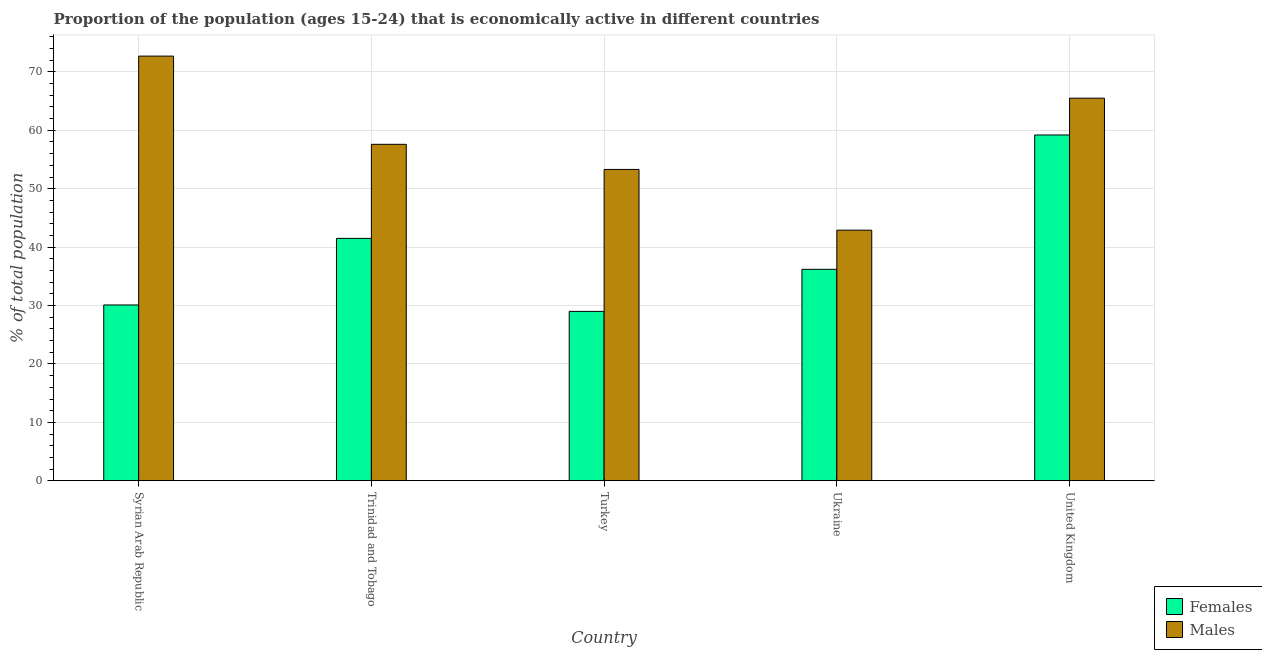How many different coloured bars are there?
Provide a succinct answer. 2. Are the number of bars per tick equal to the number of legend labels?
Ensure brevity in your answer.  Yes. Are the number of bars on each tick of the X-axis equal?
Ensure brevity in your answer.  Yes. How many bars are there on the 5th tick from the left?
Provide a succinct answer. 2. How many bars are there on the 1st tick from the right?
Your answer should be compact. 2. What is the label of the 4th group of bars from the left?
Keep it short and to the point. Ukraine. What is the percentage of economically active female population in Trinidad and Tobago?
Provide a short and direct response. 41.5. Across all countries, what is the maximum percentage of economically active male population?
Give a very brief answer. 72.7. Across all countries, what is the minimum percentage of economically active male population?
Give a very brief answer. 42.9. In which country was the percentage of economically active male population minimum?
Make the answer very short. Ukraine. What is the total percentage of economically active female population in the graph?
Your answer should be compact. 196. What is the difference between the percentage of economically active female population in Syrian Arab Republic and that in Trinidad and Tobago?
Make the answer very short. -11.4. What is the difference between the percentage of economically active male population in Syrian Arab Republic and the percentage of economically active female population in Trinidad and Tobago?
Offer a very short reply. 31.2. What is the average percentage of economically active male population per country?
Provide a succinct answer. 58.4. What is the difference between the percentage of economically active male population and percentage of economically active female population in Turkey?
Your answer should be very brief. 24.3. What is the ratio of the percentage of economically active female population in Turkey to that in Ukraine?
Your response must be concise. 0.8. What is the difference between the highest and the second highest percentage of economically active female population?
Your answer should be compact. 17.7. What is the difference between the highest and the lowest percentage of economically active male population?
Keep it short and to the point. 29.8. What does the 1st bar from the left in Syrian Arab Republic represents?
Ensure brevity in your answer.  Females. What does the 2nd bar from the right in United Kingdom represents?
Provide a succinct answer. Females. How many bars are there?
Offer a terse response. 10. Are all the bars in the graph horizontal?
Keep it short and to the point. No. How many countries are there in the graph?
Make the answer very short. 5. Are the values on the major ticks of Y-axis written in scientific E-notation?
Offer a very short reply. No. Does the graph contain any zero values?
Your answer should be very brief. No. Does the graph contain grids?
Give a very brief answer. Yes. How many legend labels are there?
Give a very brief answer. 2. What is the title of the graph?
Make the answer very short. Proportion of the population (ages 15-24) that is economically active in different countries. What is the label or title of the Y-axis?
Provide a short and direct response. % of total population. What is the % of total population in Females in Syrian Arab Republic?
Offer a terse response. 30.1. What is the % of total population of Males in Syrian Arab Republic?
Offer a terse response. 72.7. What is the % of total population in Females in Trinidad and Tobago?
Your response must be concise. 41.5. What is the % of total population in Males in Trinidad and Tobago?
Your answer should be compact. 57.6. What is the % of total population of Males in Turkey?
Your answer should be compact. 53.3. What is the % of total population in Females in Ukraine?
Your answer should be very brief. 36.2. What is the % of total population of Males in Ukraine?
Your response must be concise. 42.9. What is the % of total population in Females in United Kingdom?
Your answer should be compact. 59.2. What is the % of total population of Males in United Kingdom?
Make the answer very short. 65.5. Across all countries, what is the maximum % of total population of Females?
Your answer should be very brief. 59.2. Across all countries, what is the maximum % of total population in Males?
Your answer should be very brief. 72.7. Across all countries, what is the minimum % of total population in Females?
Make the answer very short. 29. Across all countries, what is the minimum % of total population of Males?
Your response must be concise. 42.9. What is the total % of total population of Females in the graph?
Ensure brevity in your answer.  196. What is the total % of total population of Males in the graph?
Your response must be concise. 292. What is the difference between the % of total population of Females in Syrian Arab Republic and that in Trinidad and Tobago?
Your response must be concise. -11.4. What is the difference between the % of total population of Males in Syrian Arab Republic and that in Turkey?
Your response must be concise. 19.4. What is the difference between the % of total population in Males in Syrian Arab Republic and that in Ukraine?
Give a very brief answer. 29.8. What is the difference between the % of total population in Females in Syrian Arab Republic and that in United Kingdom?
Keep it short and to the point. -29.1. What is the difference between the % of total population of Males in Syrian Arab Republic and that in United Kingdom?
Provide a succinct answer. 7.2. What is the difference between the % of total population of Males in Trinidad and Tobago and that in Turkey?
Give a very brief answer. 4.3. What is the difference between the % of total population of Males in Trinidad and Tobago and that in Ukraine?
Make the answer very short. 14.7. What is the difference between the % of total population in Females in Trinidad and Tobago and that in United Kingdom?
Provide a succinct answer. -17.7. What is the difference between the % of total population in Males in Trinidad and Tobago and that in United Kingdom?
Make the answer very short. -7.9. What is the difference between the % of total population of Females in Turkey and that in United Kingdom?
Ensure brevity in your answer.  -30.2. What is the difference between the % of total population in Males in Turkey and that in United Kingdom?
Make the answer very short. -12.2. What is the difference between the % of total population of Females in Ukraine and that in United Kingdom?
Your answer should be compact. -23. What is the difference between the % of total population of Males in Ukraine and that in United Kingdom?
Provide a short and direct response. -22.6. What is the difference between the % of total population of Females in Syrian Arab Republic and the % of total population of Males in Trinidad and Tobago?
Your response must be concise. -27.5. What is the difference between the % of total population of Females in Syrian Arab Republic and the % of total population of Males in Turkey?
Make the answer very short. -23.2. What is the difference between the % of total population of Females in Syrian Arab Republic and the % of total population of Males in Ukraine?
Your answer should be compact. -12.8. What is the difference between the % of total population of Females in Syrian Arab Republic and the % of total population of Males in United Kingdom?
Provide a short and direct response. -35.4. What is the difference between the % of total population of Females in Trinidad and Tobago and the % of total population of Males in Ukraine?
Offer a very short reply. -1.4. What is the difference between the % of total population of Females in Trinidad and Tobago and the % of total population of Males in United Kingdom?
Keep it short and to the point. -24. What is the difference between the % of total population in Females in Turkey and the % of total population in Males in Ukraine?
Offer a very short reply. -13.9. What is the difference between the % of total population of Females in Turkey and the % of total population of Males in United Kingdom?
Offer a terse response. -36.5. What is the difference between the % of total population of Females in Ukraine and the % of total population of Males in United Kingdom?
Provide a succinct answer. -29.3. What is the average % of total population in Females per country?
Your answer should be compact. 39.2. What is the average % of total population of Males per country?
Offer a very short reply. 58.4. What is the difference between the % of total population of Females and % of total population of Males in Syrian Arab Republic?
Your response must be concise. -42.6. What is the difference between the % of total population in Females and % of total population in Males in Trinidad and Tobago?
Ensure brevity in your answer.  -16.1. What is the difference between the % of total population of Females and % of total population of Males in Turkey?
Make the answer very short. -24.3. What is the ratio of the % of total population of Females in Syrian Arab Republic to that in Trinidad and Tobago?
Provide a succinct answer. 0.73. What is the ratio of the % of total population of Males in Syrian Arab Republic to that in Trinidad and Tobago?
Make the answer very short. 1.26. What is the ratio of the % of total population in Females in Syrian Arab Republic to that in Turkey?
Provide a short and direct response. 1.04. What is the ratio of the % of total population in Males in Syrian Arab Republic to that in Turkey?
Your response must be concise. 1.36. What is the ratio of the % of total population of Females in Syrian Arab Republic to that in Ukraine?
Give a very brief answer. 0.83. What is the ratio of the % of total population of Males in Syrian Arab Republic to that in Ukraine?
Provide a succinct answer. 1.69. What is the ratio of the % of total population in Females in Syrian Arab Republic to that in United Kingdom?
Your answer should be very brief. 0.51. What is the ratio of the % of total population of Males in Syrian Arab Republic to that in United Kingdom?
Offer a very short reply. 1.11. What is the ratio of the % of total population in Females in Trinidad and Tobago to that in Turkey?
Offer a terse response. 1.43. What is the ratio of the % of total population of Males in Trinidad and Tobago to that in Turkey?
Your response must be concise. 1.08. What is the ratio of the % of total population in Females in Trinidad and Tobago to that in Ukraine?
Make the answer very short. 1.15. What is the ratio of the % of total population in Males in Trinidad and Tobago to that in Ukraine?
Provide a succinct answer. 1.34. What is the ratio of the % of total population of Females in Trinidad and Tobago to that in United Kingdom?
Provide a short and direct response. 0.7. What is the ratio of the % of total population of Males in Trinidad and Tobago to that in United Kingdom?
Your answer should be very brief. 0.88. What is the ratio of the % of total population of Females in Turkey to that in Ukraine?
Your answer should be compact. 0.8. What is the ratio of the % of total population of Males in Turkey to that in Ukraine?
Your answer should be very brief. 1.24. What is the ratio of the % of total population of Females in Turkey to that in United Kingdom?
Provide a short and direct response. 0.49. What is the ratio of the % of total population of Males in Turkey to that in United Kingdom?
Provide a succinct answer. 0.81. What is the ratio of the % of total population in Females in Ukraine to that in United Kingdom?
Keep it short and to the point. 0.61. What is the ratio of the % of total population of Males in Ukraine to that in United Kingdom?
Keep it short and to the point. 0.66. What is the difference between the highest and the second highest % of total population in Males?
Give a very brief answer. 7.2. What is the difference between the highest and the lowest % of total population of Females?
Your answer should be compact. 30.2. What is the difference between the highest and the lowest % of total population of Males?
Provide a succinct answer. 29.8. 